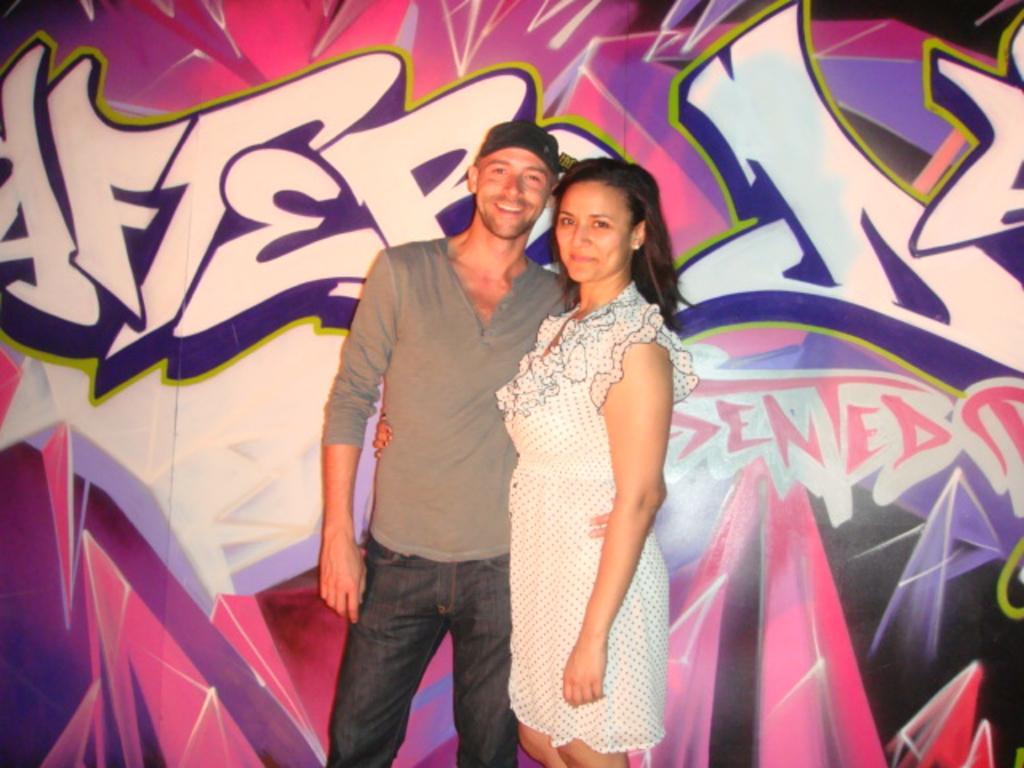Please provide a concise description of this image. In this image we can see there are two people standing and posing for a picture, behind them there is graffiti on the wall. 